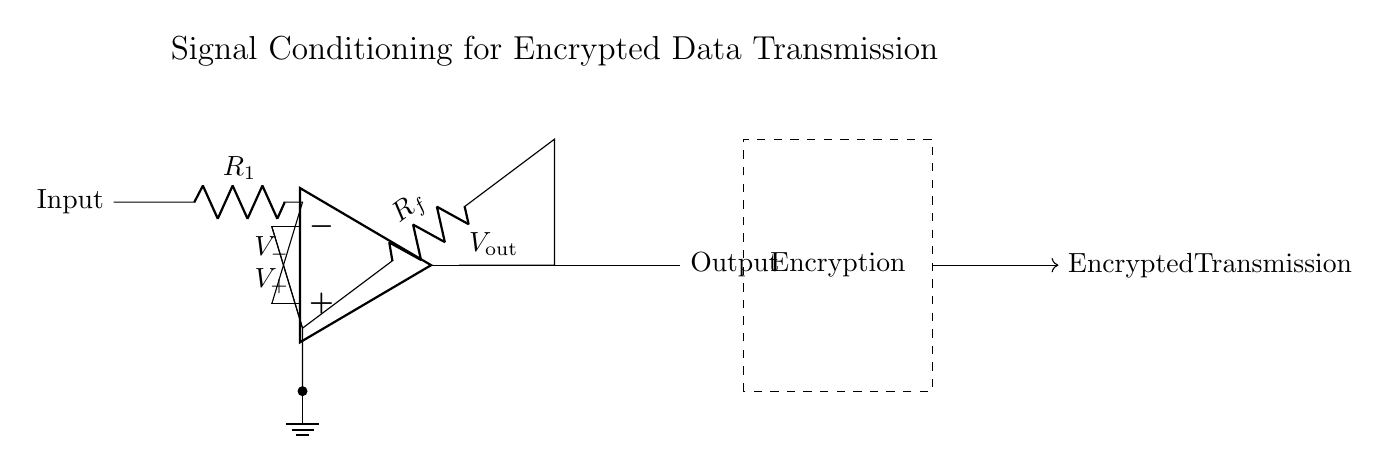What is the signal input to the operational amplifier? The circuit shows that the input signal is labeled 'Input,' indicating it is the voltage that will be conditioned by the op-amp.
Answer: Input What is the feedback resistor in the circuit? In the circuit, the resistor connected to the output and the inverting input of the op-amp is labeled 'R_f,' indicating it is the feedback resistor.
Answer: R_f What does the dashed rectangle represent? The dashed rectangle labeled 'Encryption' signifies a block in the circuit that performs the encryption of the signal after processing by the op-amp.
Answer: Encryption How many resistors are present in the circuit? The circuit diagram indicates two resistors: 'R_1' and 'R_f,' suggesting a total of two resistors involved in signal conditioning.
Answer: 2 What is the purpose of the operational amplifier in this circuit? The operational amplifier is used for signal conditioning, which means it amplifies and processes the input signal before it enters the encryption block.
Answer: Signal conditioning Which terminals of the op-amp are marked with positive and negative voltages? The positive terminal of the op-amp is marked 'V_+' and the negative terminal is marked 'V_-,' which differentiates the two inputs to the operational amplifier.
Answer: V_+ and V_- What does the arrow indicate on the output line? The arrow on the output line indicates the direction of signal flow, showing that the conditioned signal is outputted from the op-amp to the next stage in the circuit, which is encryption.
Answer: Output flow 